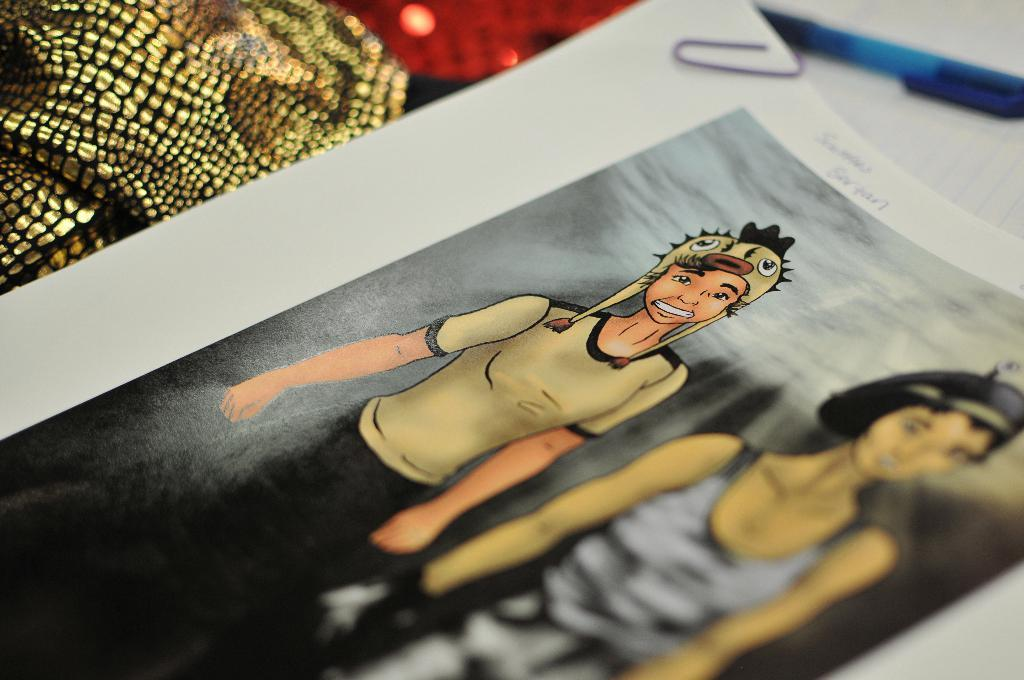What is present on the paper in the image? The paper contains an animation picture. Is there anything attached to the paper? Yes, there is a paper pin on the paper. What can be found on the paper besides the animation picture? Something is written on the paper. How many frogs are kicking a ball in the image? There are no frogs or balls present in the image. 